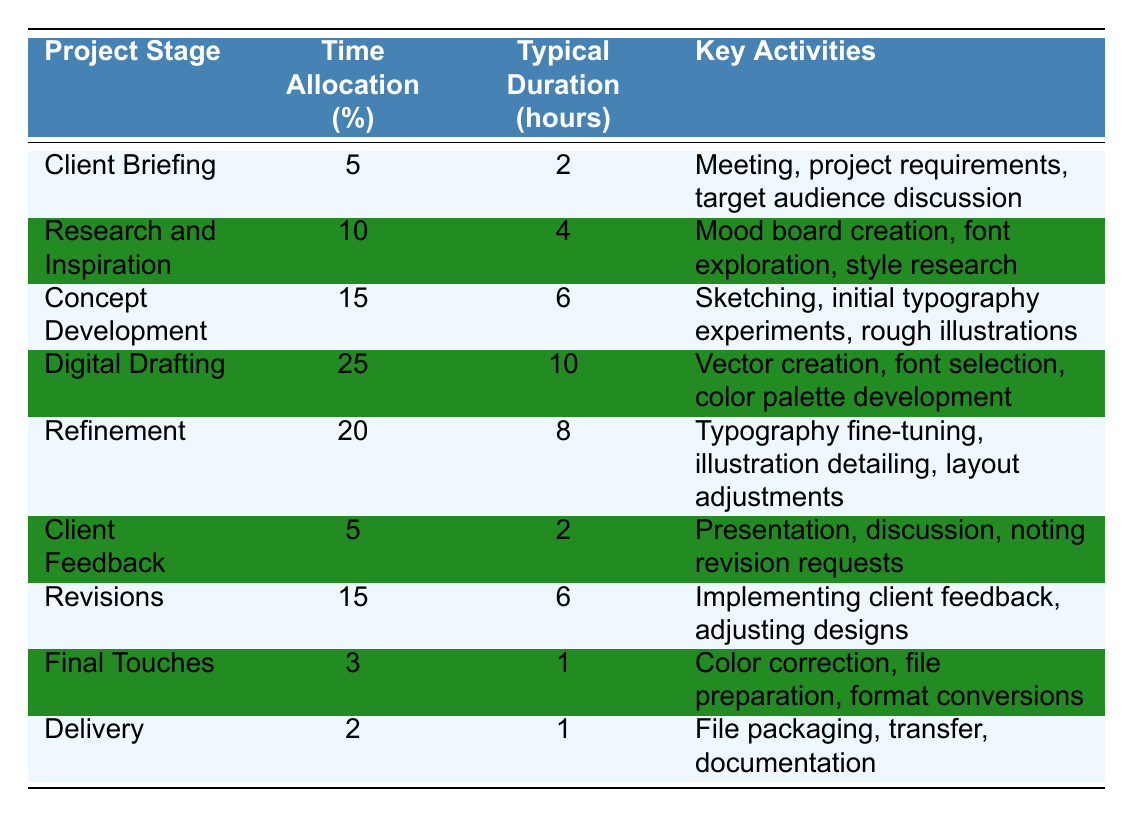What is the time allocation percentage for the "Digital Drafting" stage? According to the table, the time allocation percentage for "Digital Drafting" is specified directly as 25%.
Answer: 25% How many hours are typically spent on "Refinement"? The table indicates that "Refinement" typically takes 8 hours.
Answer: 8 hours What is the total time allocation percentage for the stages that involve client interaction (Client Briefing, Client Feedback, and Revisions)? Adding the time allocation percentages: 5% (Client Briefing) + 5% (Client Feedback) + 15% (Revisions) equals 25%.
Answer: 25% Which project stage contains the key activity of "Color correction"? The key activity "Color correction" is listed under the "Final Touches" stage.
Answer: Final Touches Is the time allocation for "Delivery" greater than that for "Final Touches"? "Delivery" has a time allocation of 2%, while "Final Touches" has 3%. Since 2% is less than 3%, the statement is false.
Answer: No What is the longest typical duration among all project stages? By examining the typical duration hours in the table, "Digital Drafting" has the longest duration at 10 hours.
Answer: 10 hours What percentage of time is allocated to "Concept Development" and "Revisions" combined? The combined time allocation is calculated as 15% (Concept Development) + 15% (Revisions) which totals 30%.
Answer: 30% Are there any project stages with a time allocation of less than 5%? The table shows that "Final Touches" has a time allocation of 3% and "Delivery" has 2%, both of which are less than 5%. Hence, the statement is true.
Answer: Yes What is the average typical duration for all project stages? To find the average, sum the hours: 2 + 4 + 6 + 10 + 8 + 2 + 6 + 1 + 1 = 40 hours. Then divide by the number of stages (9): 40/9 gives approximately 4.44 hours.
Answer: Approximately 4.44 hours Which stage has the highest percentage time allocation, and what is that percentage? The table shows that "Digital Drafting" has the highest allocation at 25%.
Answer: 25% 